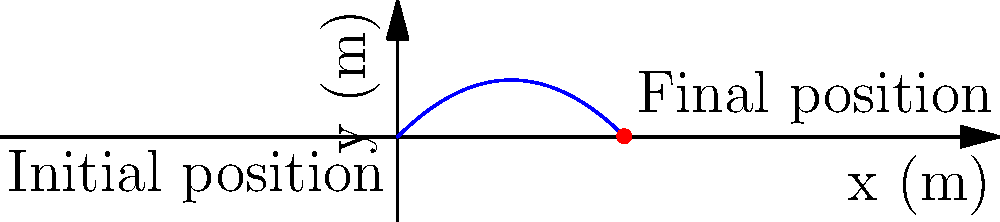A street performer is juggling balls in front of an architectural landmark. One of the balls is thrown with an initial velocity of 10 m/s at an angle of 45° to the horizontal. Assuming air resistance is negligible, at what horizontal distance from the release point does the ball reach its maximum height? Let's approach this step-by-step:

1) The horizontal distance ($x$) traveled by a projectile is given by:
   $x = v_0 \cos(\theta) t$

2) The time ($t$) to reach maximum height is when the vertical velocity becomes zero:
   $v_y = v_0 \sin(\theta) - gt = 0$
   $t = \frac{v_0 \sin(\theta)}{g}$

3) We're given:
   $v_0 = 10$ m/s
   $\theta = 45°$ = $\frac{\pi}{4}$ radians
   $g = 9.8$ m/s²

4) Let's calculate the time to reach maximum height:
   $t = \frac{10 \sin(45°)}{9.8} = \frac{10 \cdot \frac{\sqrt{2}}{2}}{9.8} \approx 0.72$ s

5) Now we can calculate the horizontal distance:
   $x = v_0 \cos(\theta) t$
   $x = 10 \cos(45°) \cdot 0.72$
   $x = 10 \cdot \frac{\sqrt{2}}{2} \cdot 0.72 \approx 5.1$ m

Therefore, the ball reaches its maximum height at a horizontal distance of approximately 5.1 meters from the release point.
Answer: 5.1 m 